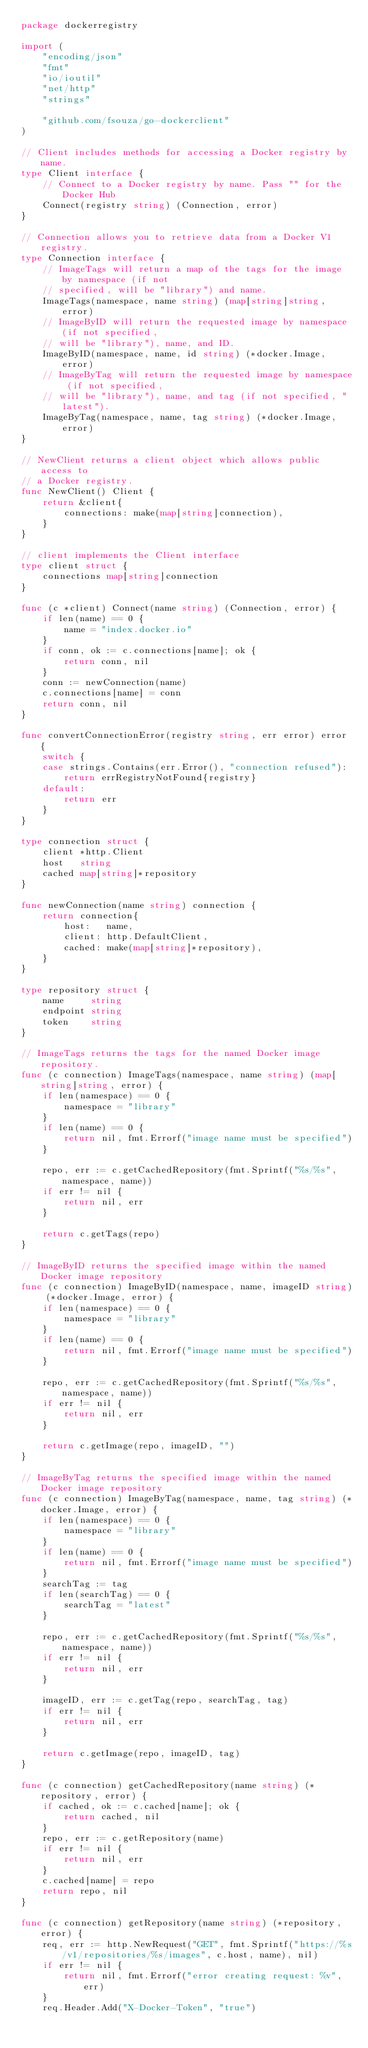Convert code to text. <code><loc_0><loc_0><loc_500><loc_500><_Go_>package dockerregistry

import (
	"encoding/json"
	"fmt"
	"io/ioutil"
	"net/http"
	"strings"

	"github.com/fsouza/go-dockerclient"
)

// Client includes methods for accessing a Docker registry by name.
type Client interface {
	// Connect to a Docker registry by name. Pass "" for the Docker Hub
	Connect(registry string) (Connection, error)
}

// Connection allows you to retrieve data from a Docker V1 registry.
type Connection interface {
	// ImageTags will return a map of the tags for the image by namespace (if not
	// specified, will be "library") and name.
	ImageTags(namespace, name string) (map[string]string, error)
	// ImageByID will return the requested image by namespace (if not specified,
	// will be "library"), name, and ID.
	ImageByID(namespace, name, id string) (*docker.Image, error)
	// ImageByTag will return the requested image by namespace (if not specified,
	// will be "library"), name, and tag (if not specified, "latest").
	ImageByTag(namespace, name, tag string) (*docker.Image, error)
}

// NewClient returns a client object which allows public access to
// a Docker registry.
func NewClient() Client {
	return &client{
		connections: make(map[string]connection),
	}
}

// client implements the Client interface
type client struct {
	connections map[string]connection
}

func (c *client) Connect(name string) (Connection, error) {
	if len(name) == 0 {
		name = "index.docker.io"
	}
	if conn, ok := c.connections[name]; ok {
		return conn, nil
	}
	conn := newConnection(name)
	c.connections[name] = conn
	return conn, nil
}

func convertConnectionError(registry string, err error) error {
	switch {
	case strings.Contains(err.Error(), "connection refused"):
		return errRegistryNotFound{registry}
	default:
		return err
	}
}

type connection struct {
	client *http.Client
	host   string
	cached map[string]*repository
}

func newConnection(name string) connection {
	return connection{
		host:   name,
		client: http.DefaultClient,
		cached: make(map[string]*repository),
	}
}

type repository struct {
	name     string
	endpoint string
	token    string
}

// ImageTags returns the tags for the named Docker image repository.
func (c connection) ImageTags(namespace, name string) (map[string]string, error) {
	if len(namespace) == 0 {
		namespace = "library"
	}
	if len(name) == 0 {
		return nil, fmt.Errorf("image name must be specified")
	}

	repo, err := c.getCachedRepository(fmt.Sprintf("%s/%s", namespace, name))
	if err != nil {
		return nil, err
	}

	return c.getTags(repo)
}

// ImageByID returns the specified image within the named Docker image repository
func (c connection) ImageByID(namespace, name, imageID string) (*docker.Image, error) {
	if len(namespace) == 0 {
		namespace = "library"
	}
	if len(name) == 0 {
		return nil, fmt.Errorf("image name must be specified")
	}

	repo, err := c.getCachedRepository(fmt.Sprintf("%s/%s", namespace, name))
	if err != nil {
		return nil, err
	}

	return c.getImage(repo, imageID, "")
}

// ImageByTag returns the specified image within the named Docker image repository
func (c connection) ImageByTag(namespace, name, tag string) (*docker.Image, error) {
	if len(namespace) == 0 {
		namespace = "library"
	}
	if len(name) == 0 {
		return nil, fmt.Errorf("image name must be specified")
	}
	searchTag := tag
	if len(searchTag) == 0 {
		searchTag = "latest"
	}

	repo, err := c.getCachedRepository(fmt.Sprintf("%s/%s", namespace, name))
	if err != nil {
		return nil, err
	}

	imageID, err := c.getTag(repo, searchTag, tag)
	if err != nil {
		return nil, err
	}

	return c.getImage(repo, imageID, tag)
}

func (c connection) getCachedRepository(name string) (*repository, error) {
	if cached, ok := c.cached[name]; ok {
		return cached, nil
	}
	repo, err := c.getRepository(name)
	if err != nil {
		return nil, err
	}
	c.cached[name] = repo
	return repo, nil
}

func (c connection) getRepository(name string) (*repository, error) {
	req, err := http.NewRequest("GET", fmt.Sprintf("https://%s/v1/repositories/%s/images", c.host, name), nil)
	if err != nil {
		return nil, fmt.Errorf("error creating request: %v", err)
	}
	req.Header.Add("X-Docker-Token", "true")</code> 